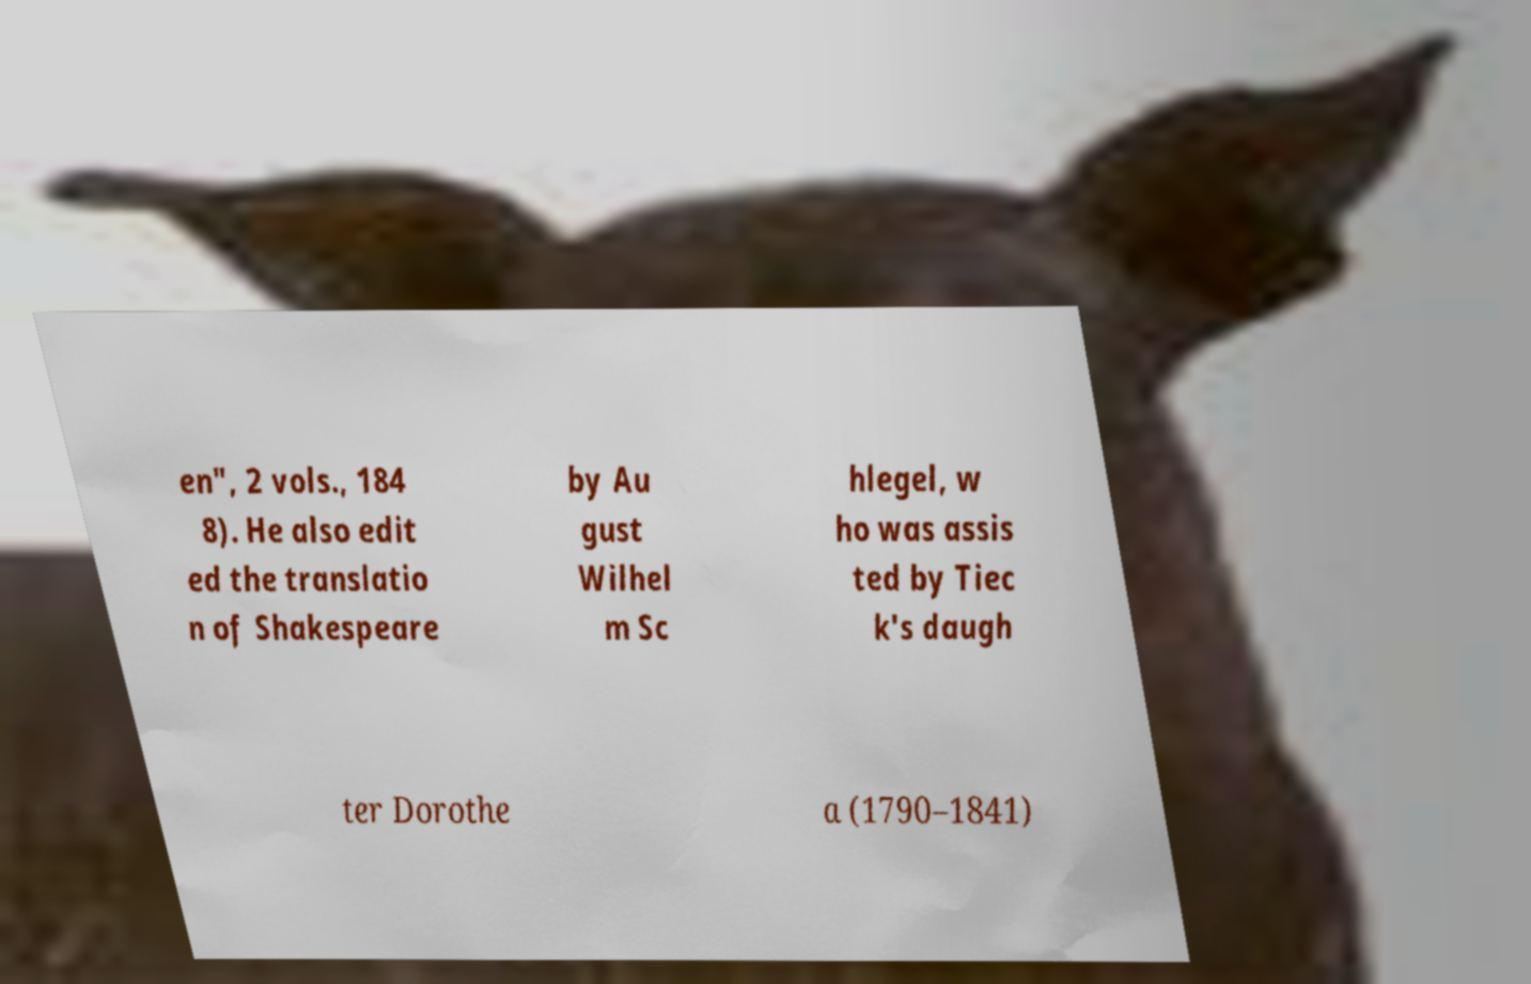Please identify and transcribe the text found in this image. en", 2 vols., 184 8). He also edit ed the translatio n of Shakespeare by Au gust Wilhel m Sc hlegel, w ho was assis ted by Tiec k's daugh ter Dorothe a (1790–1841) 